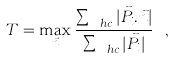<formula> <loc_0><loc_0><loc_500><loc_500>T = \max _ { \vec { n } } \frac { \sum _ { \ h c } | \vec { P _ { i } } . \vec { n } | } { \sum _ { \ h c } | \vec { P _ { i } } | } \ ,</formula> 